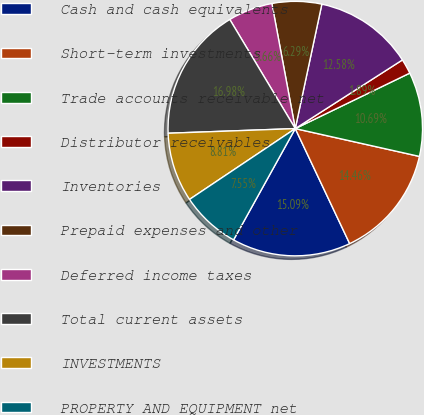<chart> <loc_0><loc_0><loc_500><loc_500><pie_chart><fcel>Cash and cash equivalents<fcel>Short-term investments<fcel>Trade accounts receivable net<fcel>Distributor receivables<fcel>Inventories<fcel>Prepaid expenses and other<fcel>Deferred income taxes<fcel>Total current assets<fcel>INVESTMENTS<fcel>PROPERTY AND EQUIPMENT net<nl><fcel>15.09%<fcel>14.46%<fcel>10.69%<fcel>1.89%<fcel>12.58%<fcel>6.29%<fcel>5.66%<fcel>16.98%<fcel>8.81%<fcel>7.55%<nl></chart> 